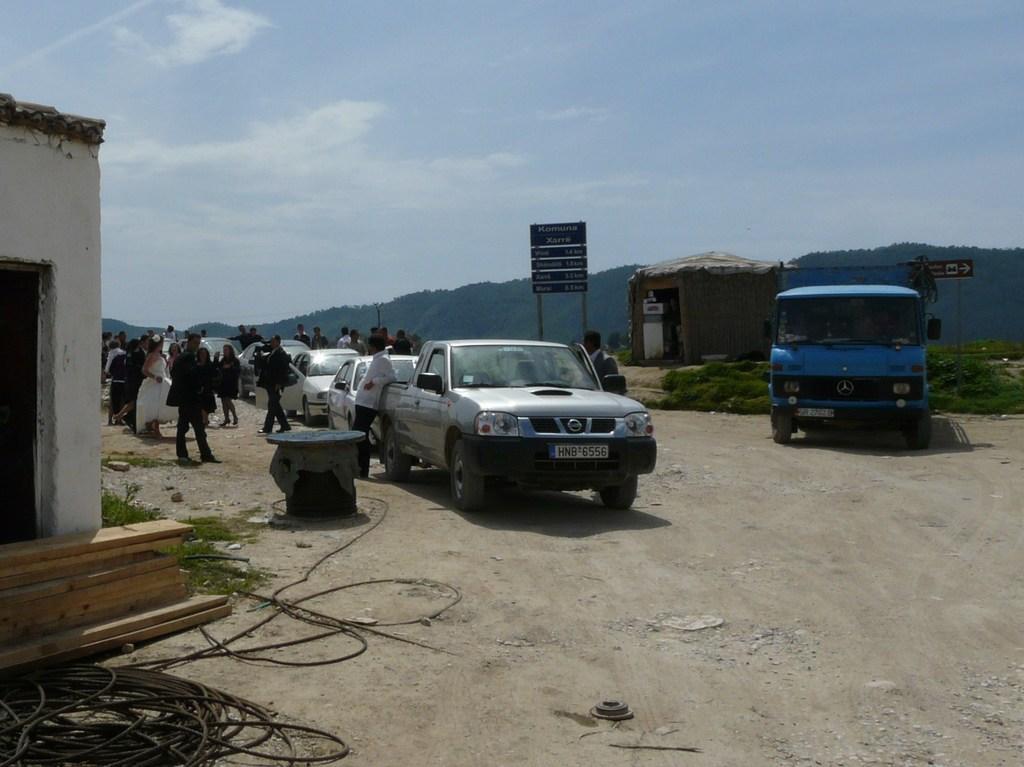In one or two sentences, can you explain what this image depicts? In this picture we can see vehicles are moving on the road, some people are walking, side we can see house and hut. 